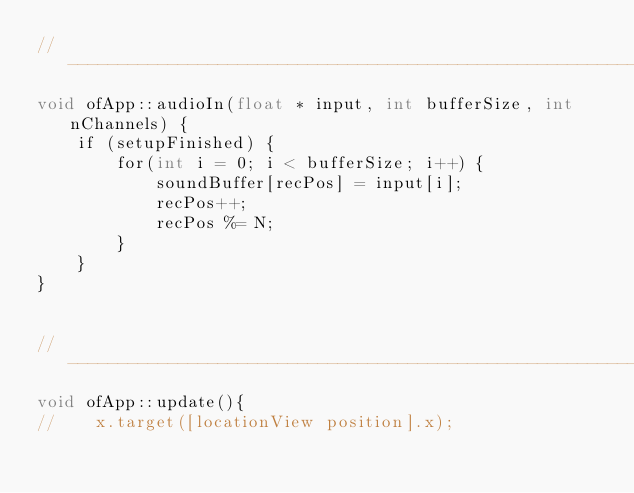Convert code to text. <code><loc_0><loc_0><loc_500><loc_500><_ObjectiveC_>//--------------------------------------------------------------
void ofApp::audioIn(float * input, int bufferSize, int nChannels) {
    if (setupFinished) {
        for(int i = 0; i < bufferSize; i++) {
            soundBuffer[recPos] = input[i];
            recPos++;
            recPos %= N;
        }
    }
}


//--------------------------------------------------------------
void ofApp::update(){
//    x.target([locationView position].x);</code> 